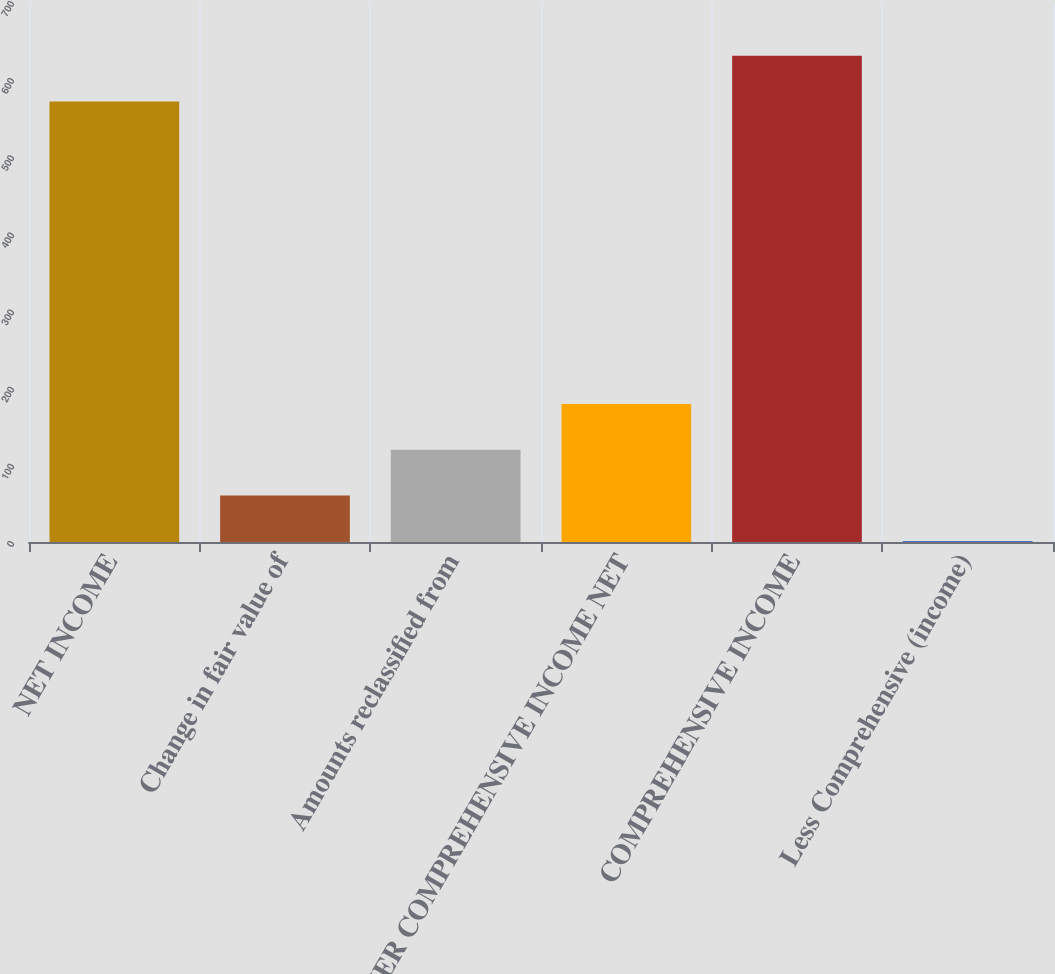<chart> <loc_0><loc_0><loc_500><loc_500><bar_chart><fcel>NET INCOME<fcel>Change in fair value of<fcel>Amounts reclassified from<fcel>OTHER COMPREHENSIVE INCOME NET<fcel>COMPREHENSIVE INCOME<fcel>Less Comprehensive (income)<nl><fcel>571<fcel>60.3<fcel>119.6<fcel>178.9<fcel>630.3<fcel>1<nl></chart> 